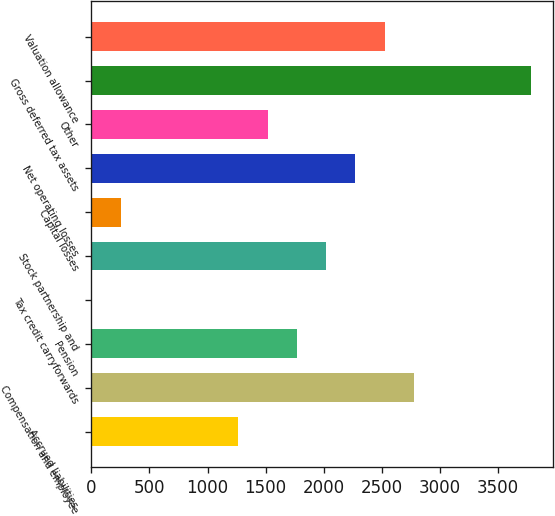Convert chart to OTSL. <chart><loc_0><loc_0><loc_500><loc_500><bar_chart><fcel>Accrued liabilities<fcel>Compensation and employee<fcel>Pension<fcel>Tax credit carryforwards<fcel>Stock partnership and<fcel>Capital losses<fcel>Net operating losses<fcel>Other<fcel>Gross deferred tax assets<fcel>Valuation allowance<nl><fcel>1266<fcel>2776.32<fcel>1769.44<fcel>7.4<fcel>2021.16<fcel>259.12<fcel>2272.88<fcel>1517.72<fcel>3783.2<fcel>2524.6<nl></chart> 